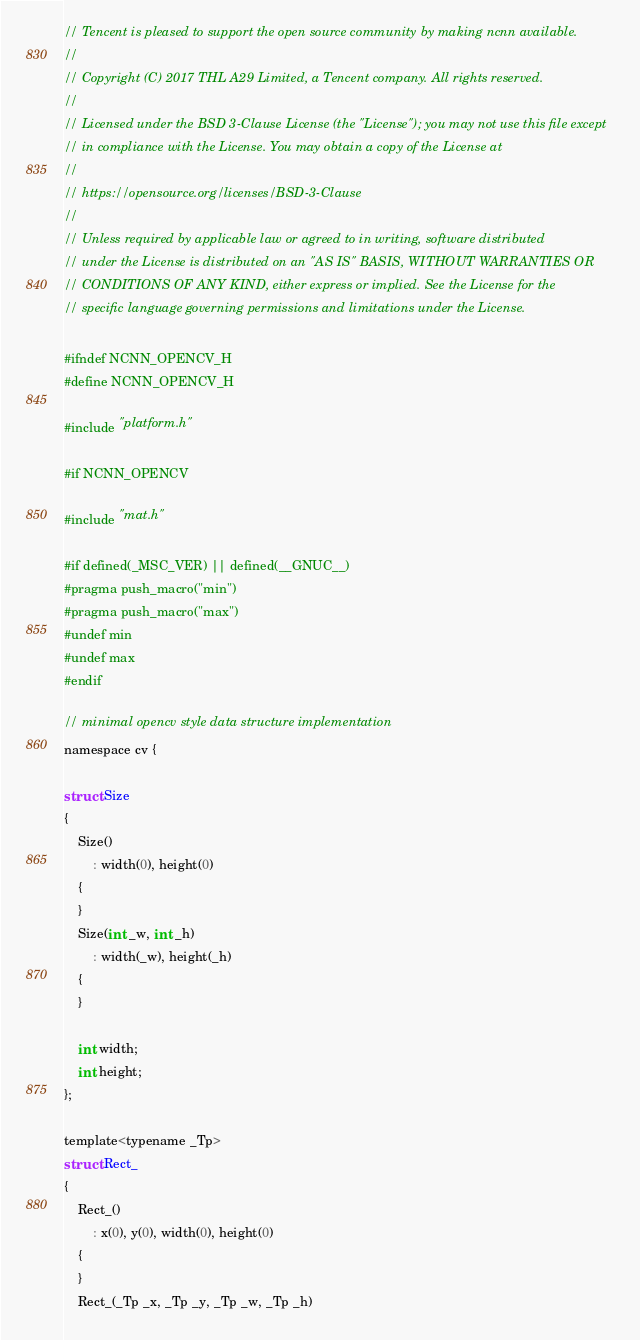Convert code to text. <code><loc_0><loc_0><loc_500><loc_500><_C_>// Tencent is pleased to support the open source community by making ncnn available.
//
// Copyright (C) 2017 THL A29 Limited, a Tencent company. All rights reserved.
//
// Licensed under the BSD 3-Clause License (the "License"); you may not use this file except
// in compliance with the License. You may obtain a copy of the License at
//
// https://opensource.org/licenses/BSD-3-Clause
//
// Unless required by applicable law or agreed to in writing, software distributed
// under the License is distributed on an "AS IS" BASIS, WITHOUT WARRANTIES OR
// CONDITIONS OF ANY KIND, either express or implied. See the License for the
// specific language governing permissions and limitations under the License.

#ifndef NCNN_OPENCV_H
#define NCNN_OPENCV_H

#include "platform.h"

#if NCNN_OPENCV

#include "mat.h"

#if defined(_MSC_VER) || defined(__GNUC__)
#pragma push_macro("min")
#pragma push_macro("max")
#undef min
#undef max
#endif

// minimal opencv style data structure implementation
namespace cv {

struct Size
{
    Size()
        : width(0), height(0)
    {
    }
    Size(int _w, int _h)
        : width(_w), height(_h)
    {
    }

    int width;
    int height;
};

template<typename _Tp>
struct Rect_
{
    Rect_()
        : x(0), y(0), width(0), height(0)
    {
    }
    Rect_(_Tp _x, _Tp _y, _Tp _w, _Tp _h)</code> 